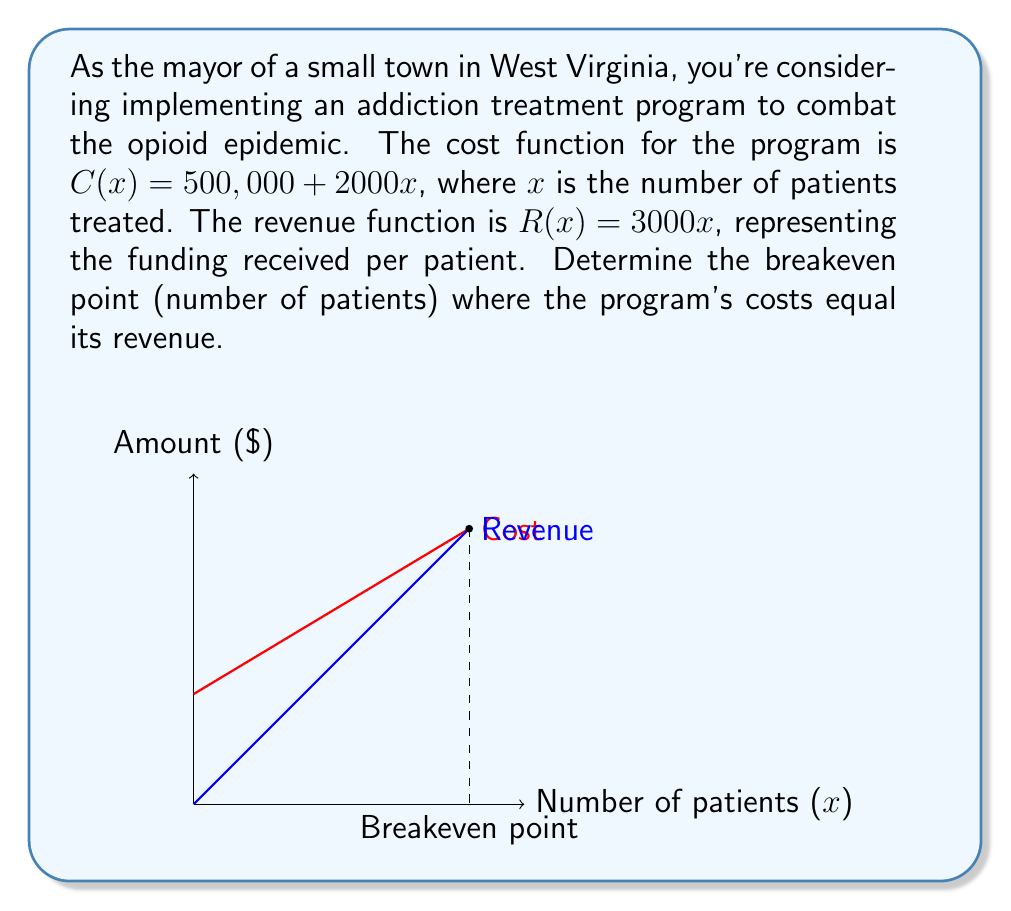Teach me how to tackle this problem. To find the breakeven point, we need to set the cost function equal to the revenue function and solve for $x$:

1) Set up the equation:
   $C(x) = R(x)$
   $500,000 + 2000x = 3000x$

2) Subtract $2000x$ from both sides:
   $500,000 = 1000x$

3) Divide both sides by 1000:
   $\frac{500,000}{1000} = x$
   $500 = x$

Therefore, the breakeven point occurs when 500 patients are treated.

To verify:
- Cost at 500 patients: $C(500) = 500,000 + 2000(500) = 1,500,000$
- Revenue at 500 patients: $R(500) = 3000(500) = 1,500,000$

As both cost and revenue equal $1,500,000 at 500 patients, this confirms the breakeven point.
Answer: 500 patients 